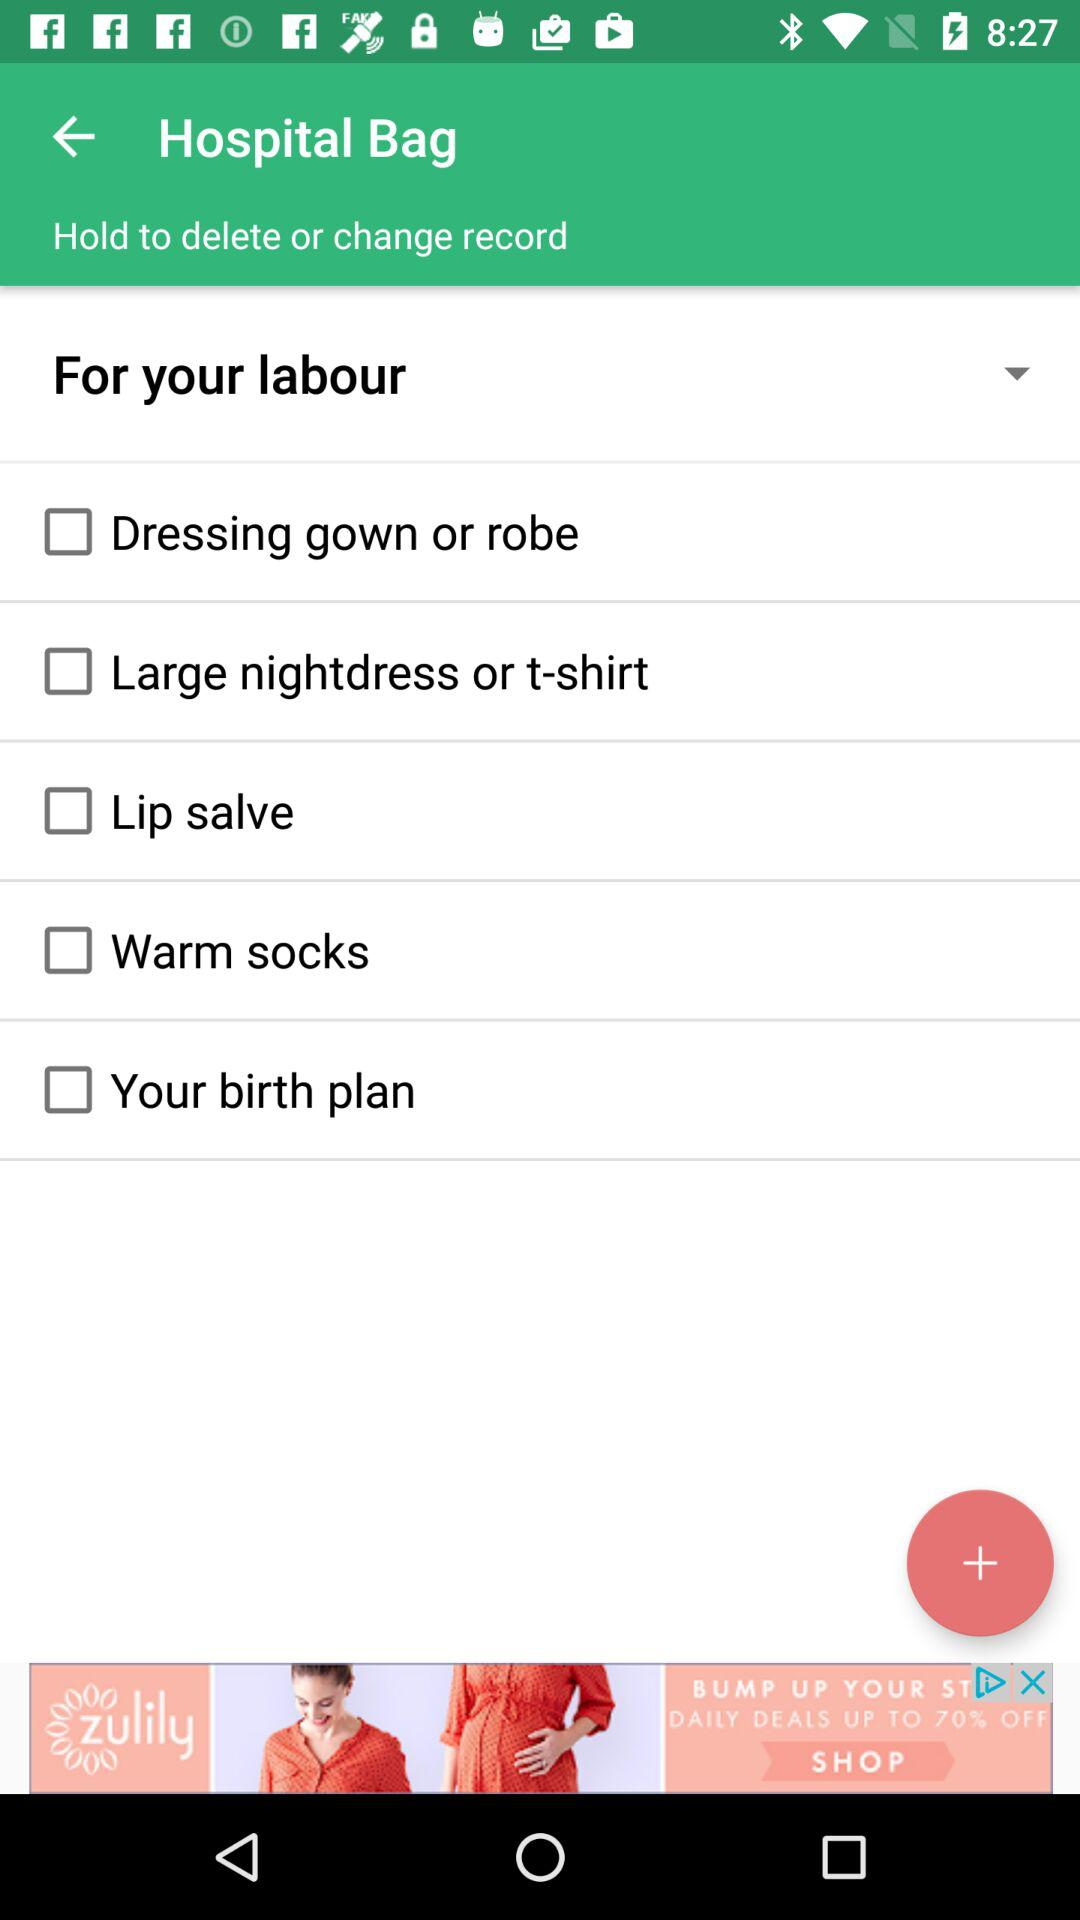What is the current status of the "Warm socks"? The current status of the "Warm socks" is "off". 